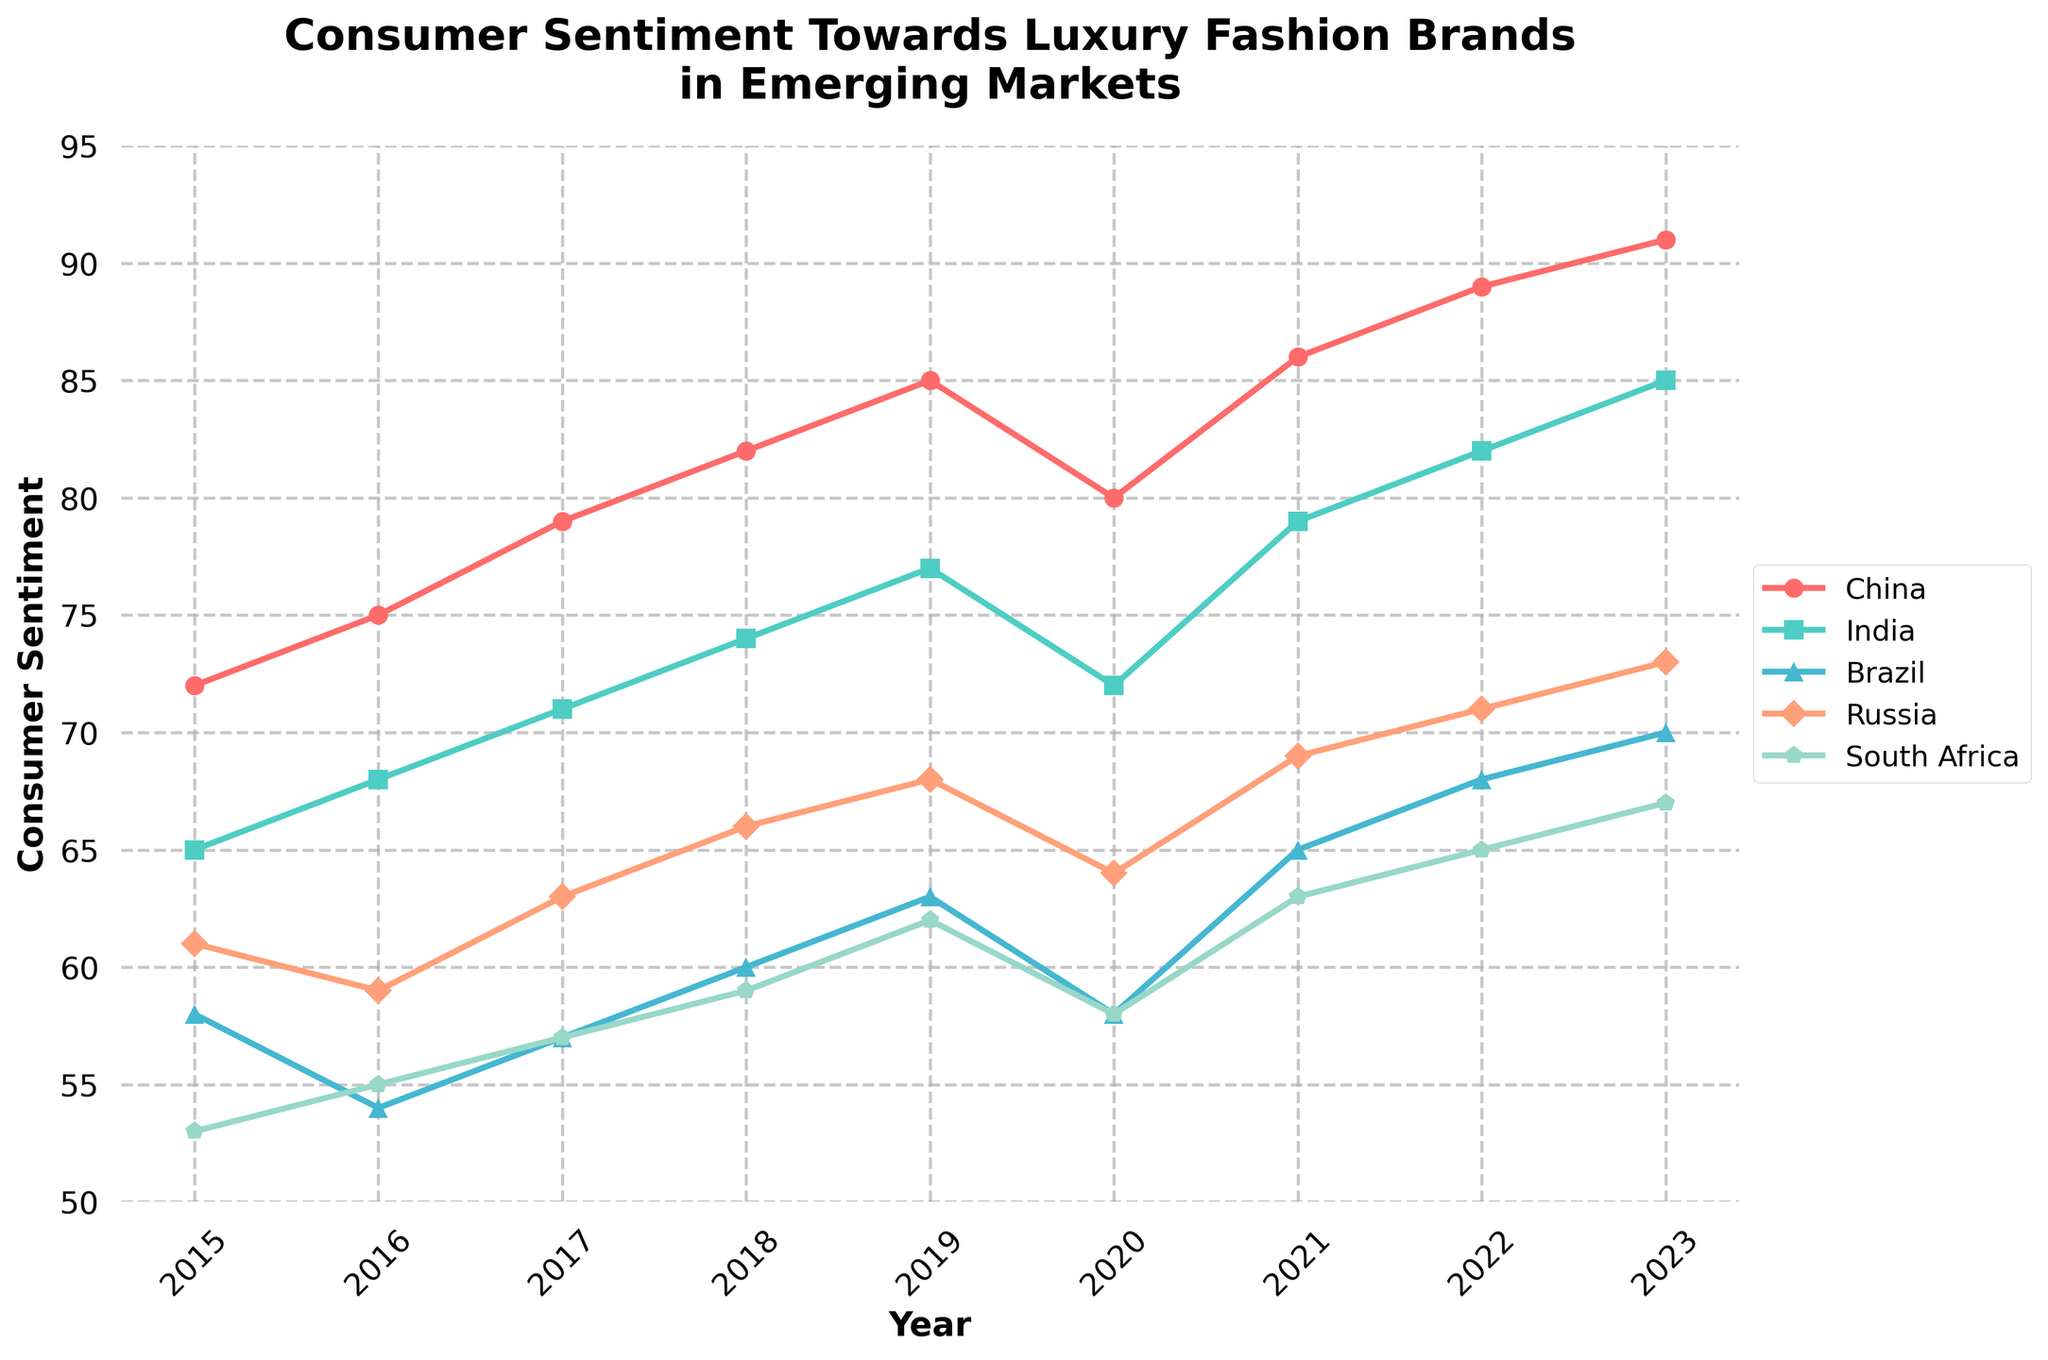What is the average consumer sentiment towards luxury fashion brands in India between 2015 and 2023? Sum all the sentiment values for India from 2015 to 2023: 65 + 68 + 71 + 74 + 77 + 72 + 79 + 82 + 85 = 673. Now, divide the total by the number of years (9): 673 / 9 ≈ 74.78
Answer: 74.78 Which country had the highest consumer sentiment in 2020? Refer to the values for the year 2020 for all countries: China (80), India (72), Brazil (58), Russia (64), and South Africa (58). China has the highest sentiment value with 80.
Answer: China In which year did South Africa have the lowest consumer sentiment? Compare the sentiment values for South Africa across all the years: 2015 (53), 2016 (55), 2017 (57), 2018 (59), 2019 (62), 2020 (58), 2021 (63), 2022 (65), 2023 (67). The lowest value is in 2015.
Answer: 2015 What is the range of consumer sentiment for Brazil from 2015 to 2023? Find the highest and lowest sentiment values for Brazil between 2015 and 2023. The highest value is 70 (in 2023), and the lowest is 54 (in 2016). The range is 70 - 54 = 16.
Answer: 16 Did any country experience a decrease in consumer sentiment between 2019 and 2020? Compare the sentiment values for all countries in 2019 and 2020: China (85 to 80), India (77 to 72), Brazil (63 to 58), Russia (68 to 64), South Africa (62 to 58). All countries show a decrease in sentiment.
Answer: Yes How much did the consumer sentiment for Russia change from 2017 to 2023? Subtract the sentiment value of Russia in 2017 from the value in 2023: 73 - 63 = 10.
Answer: 10 Which year showed the steepest increase in consumer sentiment for China? Compare the year-on-year increment for China: 2015 to 2016 (+3), 2016 to 2017 (+4), 2017 to 2018 (+3), 2018 to 2019 (+3), 2019 to 2020 (-5), 2020 to 2021 (+6), 2021 to 2022 (+3), 2022 to 2023 (+2). The steepest increase is from 2020 to 2021, with a rise of +6.
Answer: 2021 Is the sentiment growth trend for South Africa positive or negative from 2015 to 2023? Observe the trend for South Africa from 2015 (53) to 2023 (67). The overall trend shows an increase in sentiment values.
Answer: Positive 